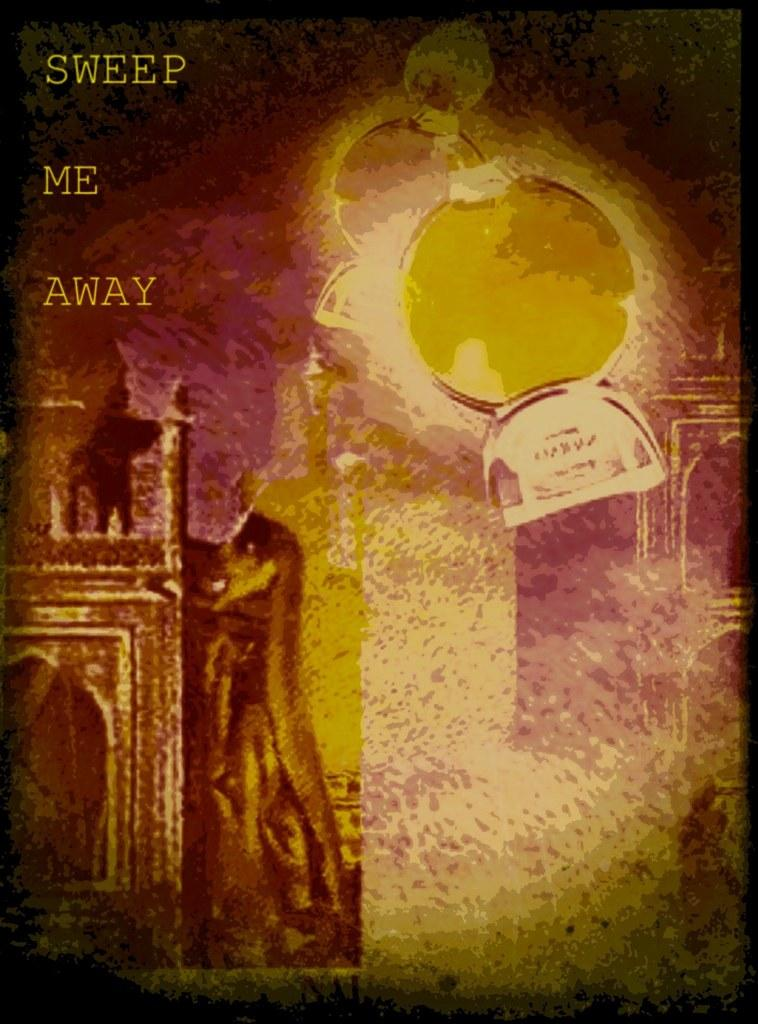Provide a one-sentence caption for the provided image. An ad for something with the words "Sweep Me Away" in the top left corner. 